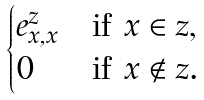Convert formula to latex. <formula><loc_0><loc_0><loc_500><loc_500>\begin{cases} e _ { x , x } ^ { z } & \text {if $x\in z$,} \\ 0 & \text {if $x\notin z$.} \end{cases}</formula> 